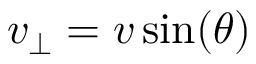Convert formula to latex. <formula><loc_0><loc_0><loc_500><loc_500>v _ { \perp } = v \sin ( \theta )</formula> 